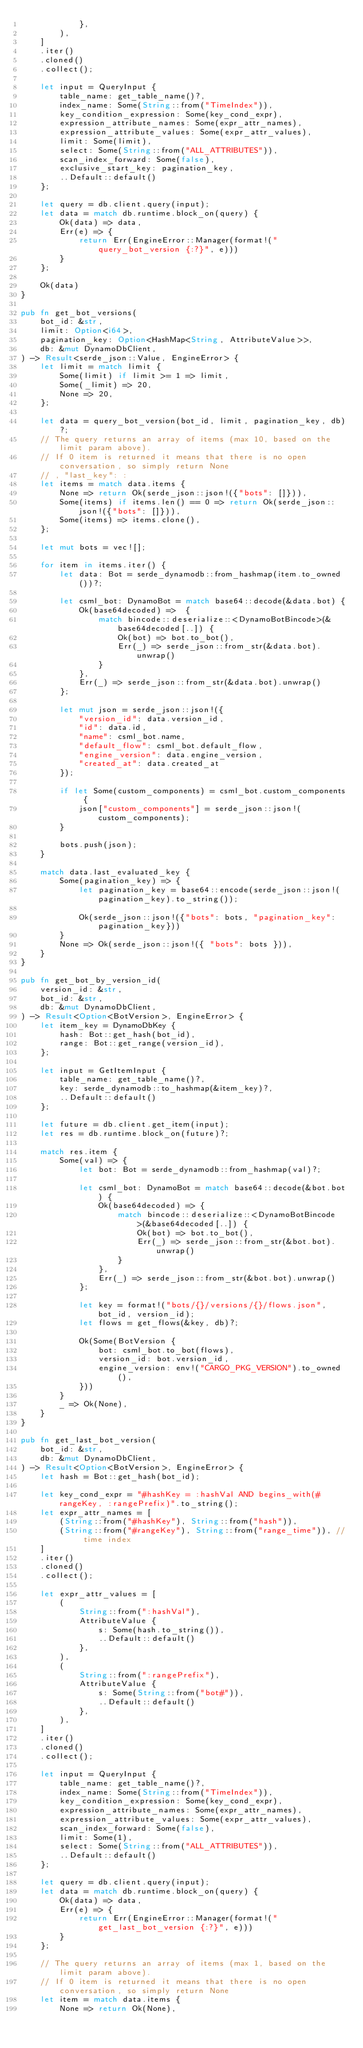Convert code to text. <code><loc_0><loc_0><loc_500><loc_500><_Rust_>            },
        ),
    ]
    .iter()
    .cloned()
    .collect();

    let input = QueryInput {
        table_name: get_table_name()?,
        index_name: Some(String::from("TimeIndex")),
        key_condition_expression: Some(key_cond_expr),
        expression_attribute_names: Some(expr_attr_names),
        expression_attribute_values: Some(expr_attr_values),
        limit: Some(limit),
        select: Some(String::from("ALL_ATTRIBUTES")),
        scan_index_forward: Some(false),
        exclusive_start_key: pagination_key,
        ..Default::default()
    };

    let query = db.client.query(input);
    let data = match db.runtime.block_on(query) {
        Ok(data) => data,
        Err(e) => {
            return Err(EngineError::Manager(format!("query_bot_version {:?}", e)))
        }
    };

    Ok(data)
}

pub fn get_bot_versions(
    bot_id: &str,
    limit: Option<i64>,
    pagination_key: Option<HashMap<String, AttributeValue>>,
    db: &mut DynamoDbClient,
) -> Result<serde_json::Value, EngineError> {
    let limit = match limit {
        Some(limit) if limit >= 1 => limit,
        Some(_limit) => 20,
        None => 20,
    };

    let data = query_bot_version(bot_id, limit, pagination_key, db)?;
    // The query returns an array of items (max 10, based on the limit param above).
    // If 0 item is returned it means that there is no open conversation, so simply return None
    // , "last_key": :
    let items = match data.items {
        None => return Ok(serde_json::json!({"bots": []})),
        Some(items) if items.len() == 0 => return Ok(serde_json::json!({"bots": []})),
        Some(items) => items.clone(),
    };

    let mut bots = vec![];

    for item in items.iter() {
        let data: Bot = serde_dynamodb::from_hashmap(item.to_owned())?;

        let csml_bot: DynamoBot = match base64::decode(&data.bot) {
            Ok(base64decoded) =>  {
                match bincode::deserialize::<DynamoBotBincode>(&base64decoded[..]) {
                    Ok(bot) => bot.to_bot(),
                    Err(_) => serde_json::from_str(&data.bot).unwrap()
                }
            },
            Err(_) => serde_json::from_str(&data.bot).unwrap()
        };

        let mut json = serde_json::json!({
            "version_id": data.version_id,
            "id": data.id,
            "name": csml_bot.name,
            "default_flow": csml_bot.default_flow,
            "engine_version": data.engine_version,
            "created_at": data.created_at
        });

        if let Some(custom_components) = csml_bot.custom_components {
            json["custom_components"] = serde_json::json!(custom_components);
        }

        bots.push(json);
    }

    match data.last_evaluated_key {
        Some(pagination_key) => {
            let pagination_key = base64::encode(serde_json::json!(pagination_key).to_string());

            Ok(serde_json::json!({"bots": bots, "pagination_key": pagination_key}))
        }
        None => Ok(serde_json::json!({ "bots": bots })),
    }
}

pub fn get_bot_by_version_id(
    version_id: &str,
    bot_id: &str,
    db: &mut DynamoDbClient,
) -> Result<Option<BotVersion>, EngineError> {
    let item_key = DynamoDbKey {
        hash: Bot::get_hash(bot_id),
        range: Bot::get_range(version_id),
    };

    let input = GetItemInput {
        table_name: get_table_name()?,
        key: serde_dynamodb::to_hashmap(&item_key)?,
        ..Default::default()
    };

    let future = db.client.get_item(input);
    let res = db.runtime.block_on(future)?;

    match res.item {
        Some(val) => {
            let bot: Bot = serde_dynamodb::from_hashmap(val)?;

            let csml_bot: DynamoBot = match base64::decode(&bot.bot) {
                Ok(base64decoded) => {
                    match bincode::deserialize::<DynamoBotBincode>(&base64decoded[..]) {
                        Ok(bot) => bot.to_bot(),
                        Err(_) => serde_json::from_str(&bot.bot).unwrap()
                    }
                },
                Err(_) => serde_json::from_str(&bot.bot).unwrap()
            };

            let key = format!("bots/{}/versions/{}/flows.json", bot_id, version_id);
            let flows = get_flows(&key, db)?;

            Ok(Some(BotVersion {
                bot: csml_bot.to_bot(flows),
                version_id: bot.version_id,
                engine_version: env!("CARGO_PKG_VERSION").to_owned(),
            }))
        }
        _ => Ok(None),
    }
}

pub fn get_last_bot_version(
    bot_id: &str,
    db: &mut DynamoDbClient,
) -> Result<Option<BotVersion>, EngineError> {
    let hash = Bot::get_hash(bot_id);

    let key_cond_expr = "#hashKey = :hashVal AND begins_with(#rangeKey, :rangePrefix)".to_string();
    let expr_attr_names = [
        (String::from("#hashKey"), String::from("hash")),
        (String::from("#rangeKey"), String::from("range_time")), // time index
    ]
    .iter()
    .cloned()
    .collect();

    let expr_attr_values = [
        (
            String::from(":hashVal"),
            AttributeValue {
                s: Some(hash.to_string()),
                ..Default::default()
            },
        ),
        (
            String::from(":rangePrefix"),
            AttributeValue {
                s: Some(String::from("bot#")),
                ..Default::default()
            },
        ),
    ]
    .iter()
    .cloned()
    .collect();

    let input = QueryInput {
        table_name: get_table_name()?,
        index_name: Some(String::from("TimeIndex")),
        key_condition_expression: Some(key_cond_expr),
        expression_attribute_names: Some(expr_attr_names),
        expression_attribute_values: Some(expr_attr_values),
        scan_index_forward: Some(false),
        limit: Some(1),
        select: Some(String::from("ALL_ATTRIBUTES")),
        ..Default::default()
    };

    let query = db.client.query(input);
    let data = match db.runtime.block_on(query) {
        Ok(data) => data,
        Err(e) => {
            return Err(EngineError::Manager(format!("get_last_bot_version {:?}", e)))
        }
    };

    // The query returns an array of items (max 1, based on the limit param above).
    // If 0 item is returned it means that there is no open conversation, so simply return None
    let item = match data.items {
        None => return Ok(None),</code> 